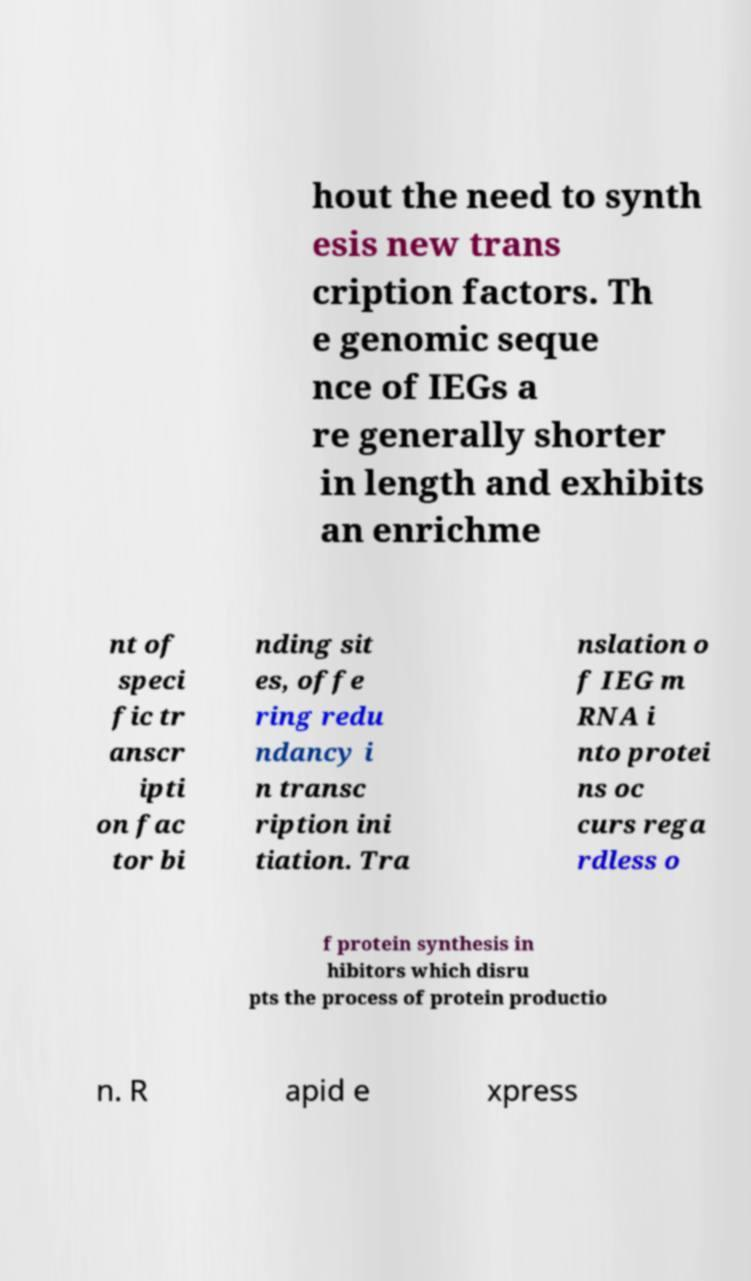Could you extract and type out the text from this image? hout the need to synth esis new trans cription factors. Th e genomic seque nce of IEGs a re generally shorter in length and exhibits an enrichme nt of speci fic tr anscr ipti on fac tor bi nding sit es, offe ring redu ndancy i n transc ription ini tiation. Tra nslation o f IEG m RNA i nto protei ns oc curs rega rdless o f protein synthesis in hibitors which disru pts the process of protein productio n. R apid e xpress 